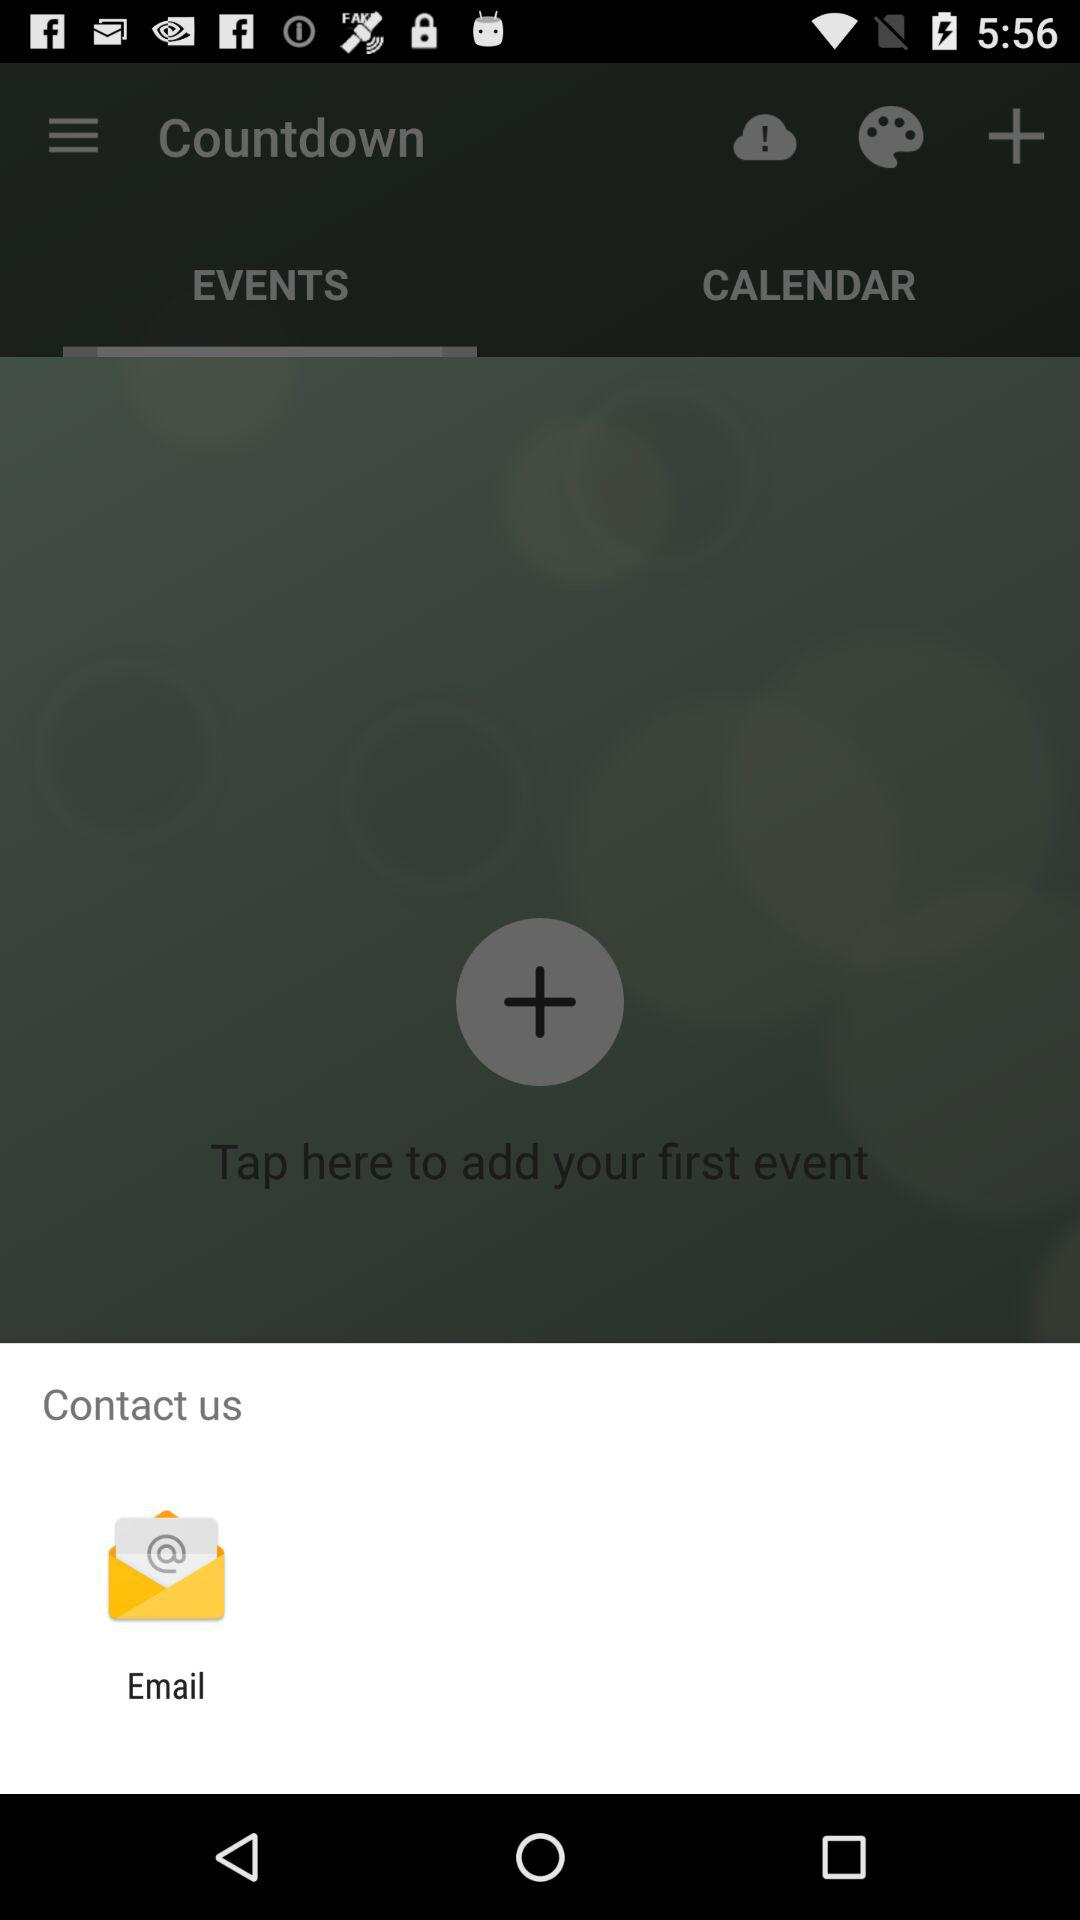What application can be used to contact? The application that can be used to contact is "Email". 